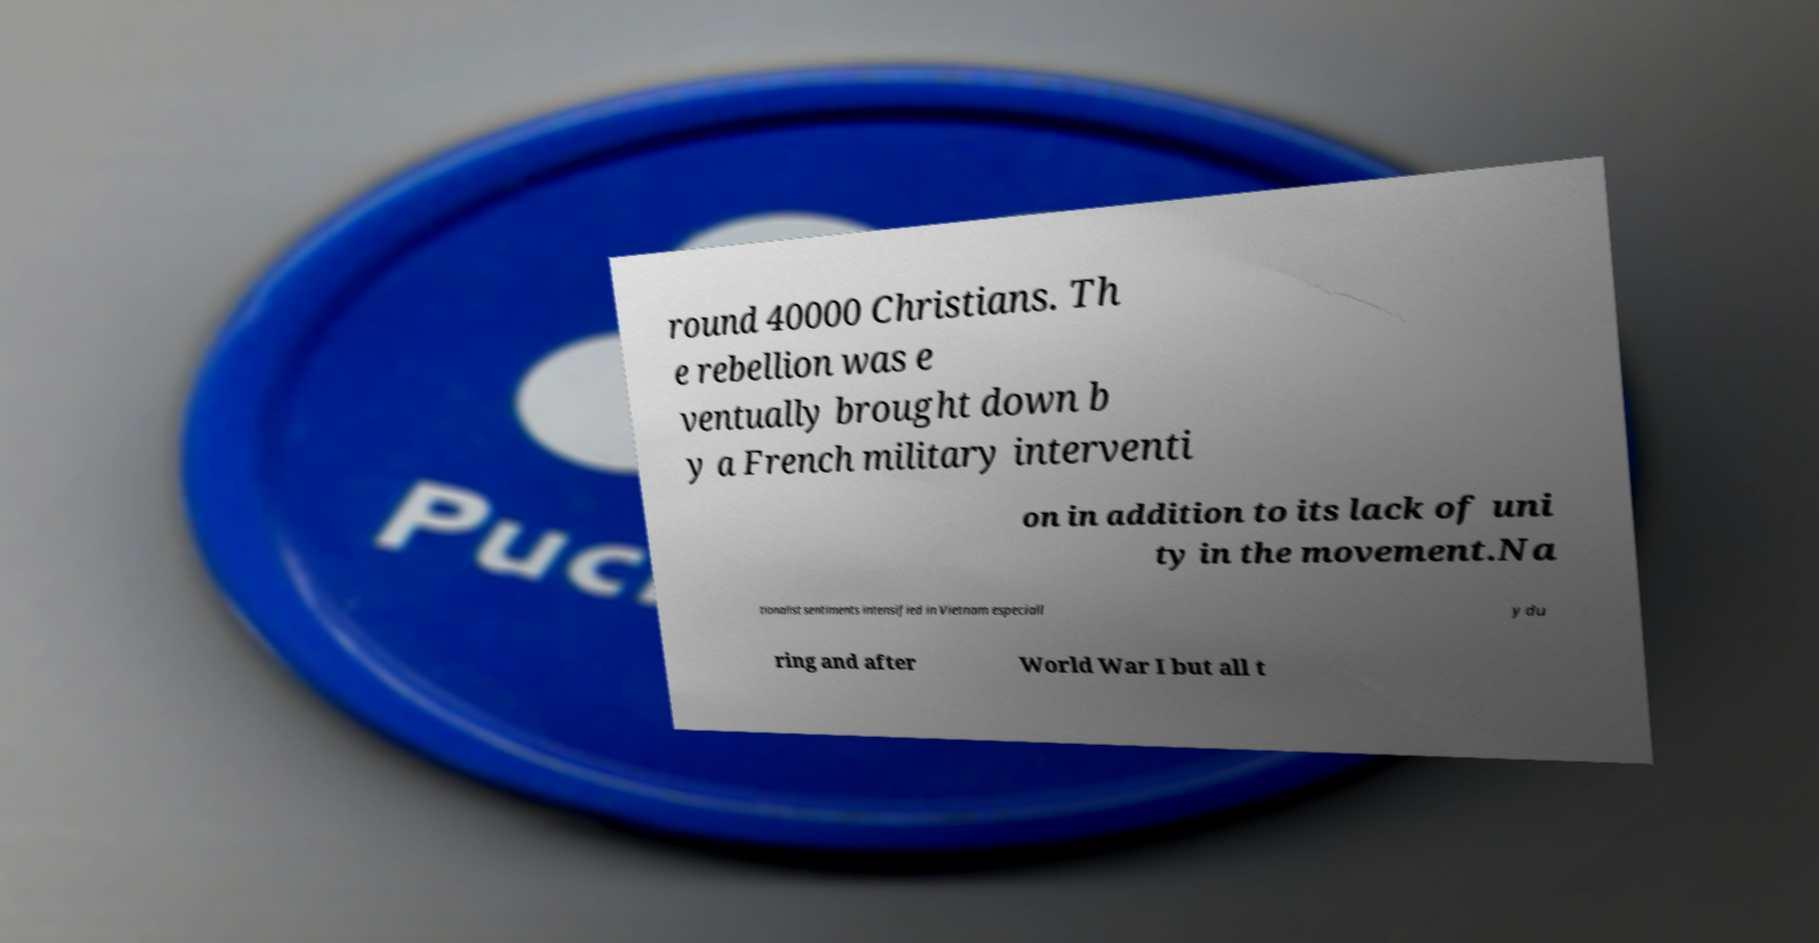I need the written content from this picture converted into text. Can you do that? round 40000 Christians. Th e rebellion was e ventually brought down b y a French military interventi on in addition to its lack of uni ty in the movement.Na tionalist sentiments intensified in Vietnam especiall y du ring and after World War I but all t 